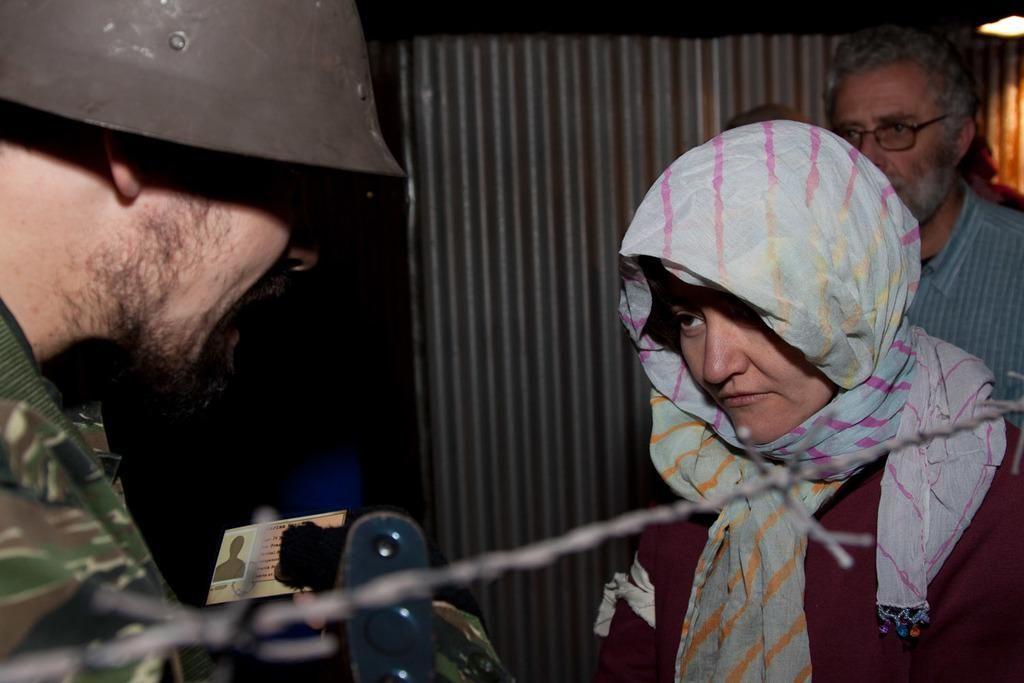How many people are in the image? There are two men and a woman in the image, making a total of three people. What is one of the men wearing? One of the men is wearing a helmet. What can be seen in the background of the image? There is a light visible in the background of the image. What type of material is present in the image? Fencing wire is visible in the image. Can you tell me how many sinks are visible in the image? There are no sinks present in the image. Is there a dog interacting with the people in the image? There is no dog visible in the image. 